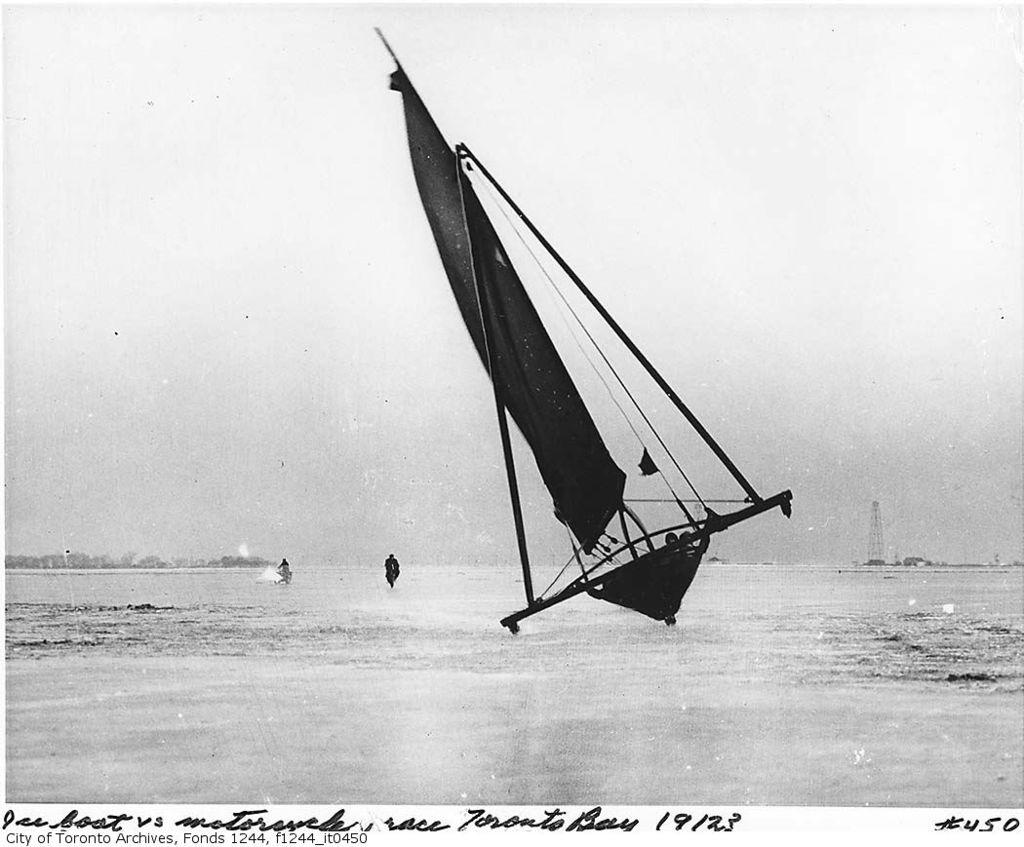What is the main subject of the image? The main subject of the image is water. What can be seen floating on the water? There are ships on the water. What type of vegetation is visible in the background of the image? There are trees in the background of the image. What other structure can be seen in the background of the image? There is a tower in the background of the image. What is visible in the sky in the image? The sky is visible in the background of the image. What information is provided at the bottom of the image? There is text written at the bottom of the image. What team is responsible for the friction in the image? There is no team present in the image, and friction is not a concept that can be applied to an image. 